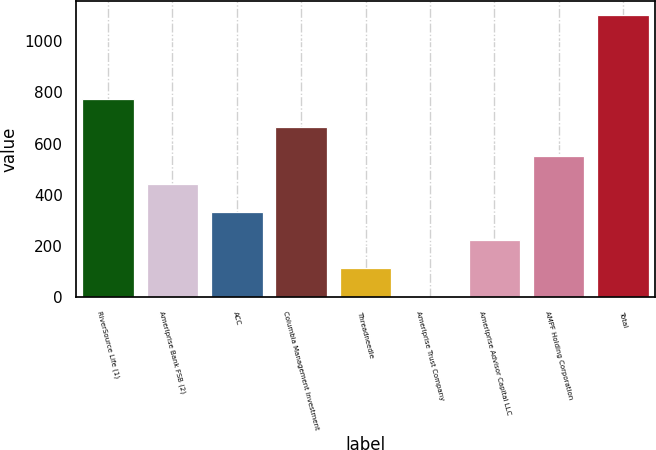Convert chart to OTSL. <chart><loc_0><loc_0><loc_500><loc_500><bar_chart><fcel>RiverSource Life (1)<fcel>Ameriprise Bank FSB (2)<fcel>ACC<fcel>Columbia Management Investment<fcel>Threadneedle<fcel>Ameriprise Trust Company<fcel>Ameriprise Advisor Capital LLC<fcel>AMPF Holding Corporation<fcel>Total<nl><fcel>773<fcel>443<fcel>333<fcel>663<fcel>113<fcel>3<fcel>223<fcel>553<fcel>1103<nl></chart> 